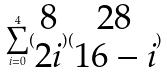Convert formula to latex. <formula><loc_0><loc_0><loc_500><loc_500>\sum _ { i = 0 } ^ { 4 } ( \begin{matrix} 8 \\ 2 i \end{matrix} ) ( \begin{matrix} 2 8 \\ 1 6 - i \end{matrix} )</formula> 